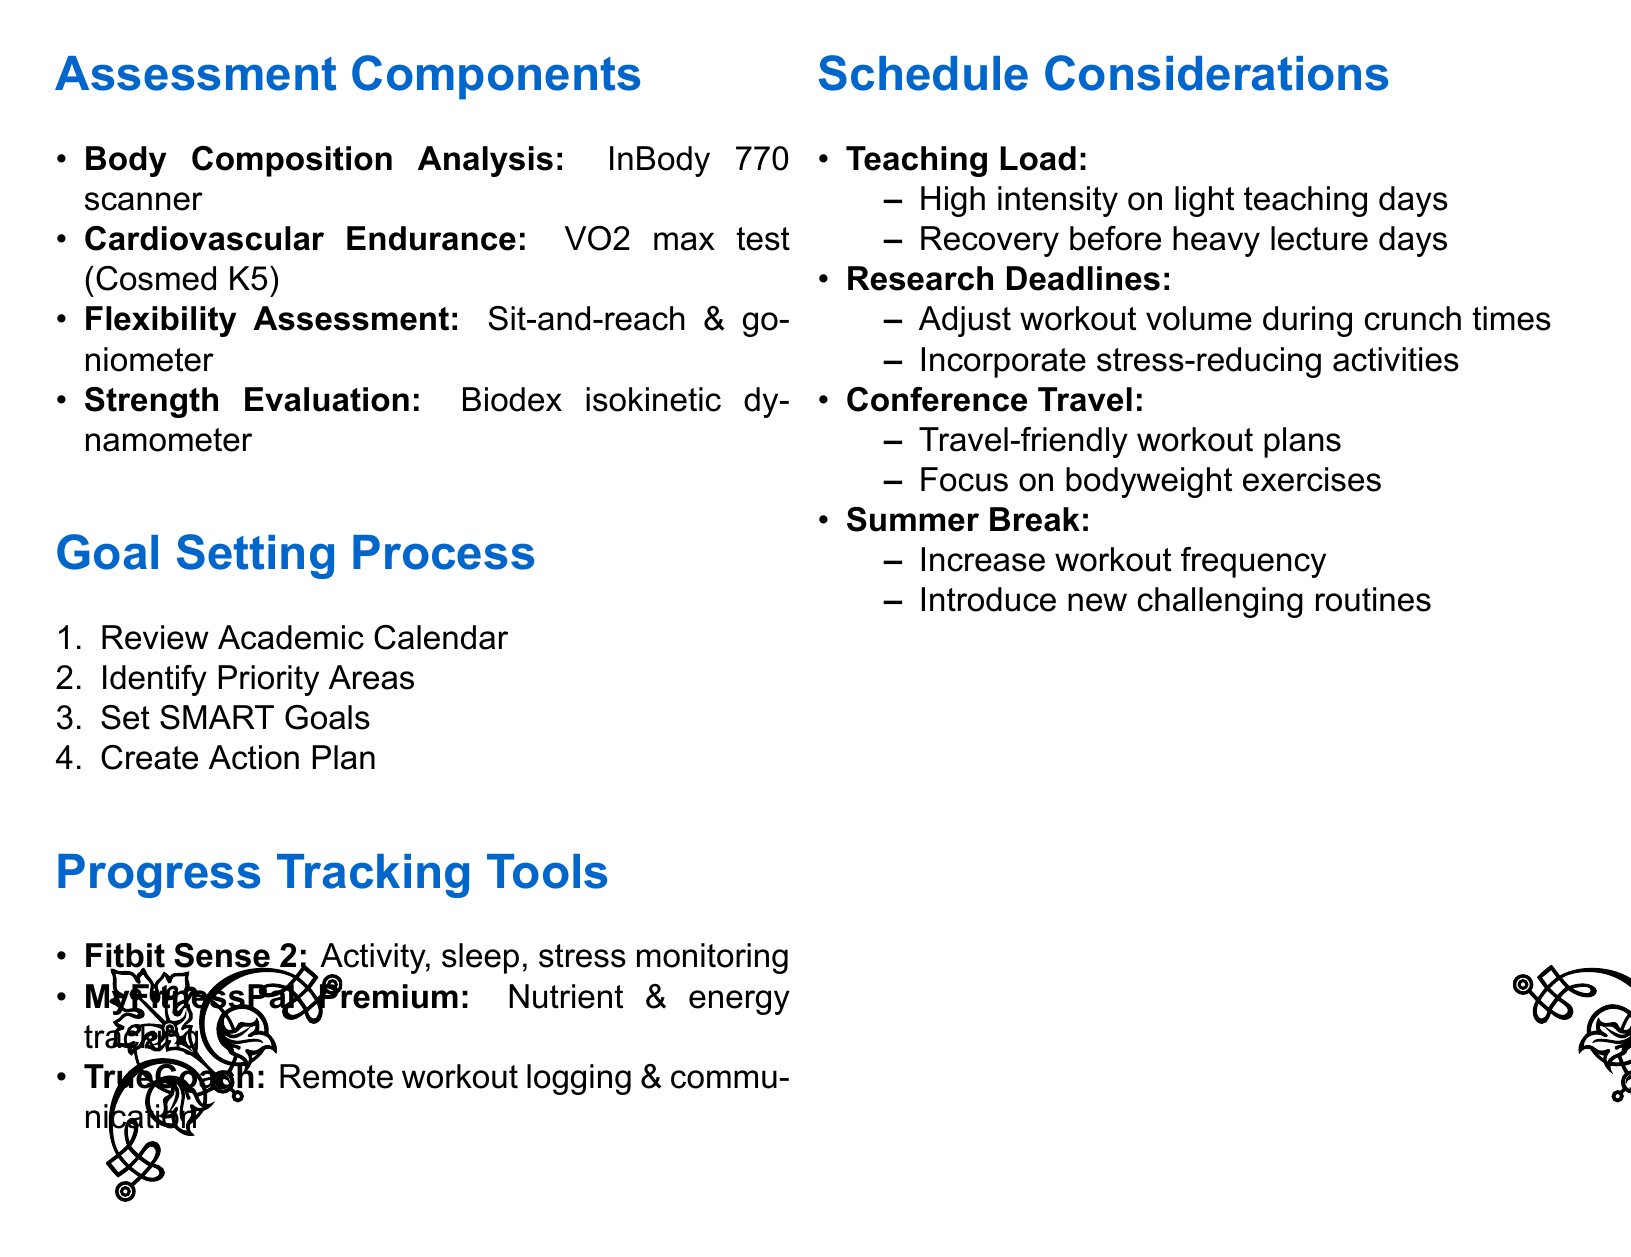What is the first assessment component listed? The first assessment component is Body Composition Analysis, and it is listed under Assessment Components in the document.
Answer: Body Composition Analysis What tool is used for the Cardiovascular Endurance Test? The Cardiovascular Endurance Test is performed using the Cosmed K5 metabolic analyzer as specified in the document.
Answer: Cosmed K5 What is the purpose of setting SMART Goals? The purpose of setting SMART Goals is to create clear targets that can be tracked and adjusted throughout the quarter, as stated in the Goal Setting Process.
Answer: Create clear targets Which device is mentioned for monitoring sleep patterns? The document states that the Fitbit Sense 2 is used for monitoring daily activity levels, sleep patterns, and stress levels.
Answer: Fitbit Sense 2 How does teaching load impact workout scheduling? The document indicates that a higher intensity workout should be planned during lighter teaching days, addressing the impact of teaching load.
Answer: Higher intensity workouts What is the last step in the Goal Setting Process? The last step outlined in the Goal Setting Process is to Create Action Plan, as seen in the enumerated list.
Answer: Create Action Plan What is one consideration during conference travel? The document mentions preparing travel-friendly workout plans as a consideration during conference travel.
Answer: Travel-friendly workout plans What activity is suggested during high-pressure research weeks? It is suggested to incorporate stress-reducing activities like yoga or meditation during high-pressure research weeks, according to the Schedule Considerations.
Answer: Yoga or meditation 